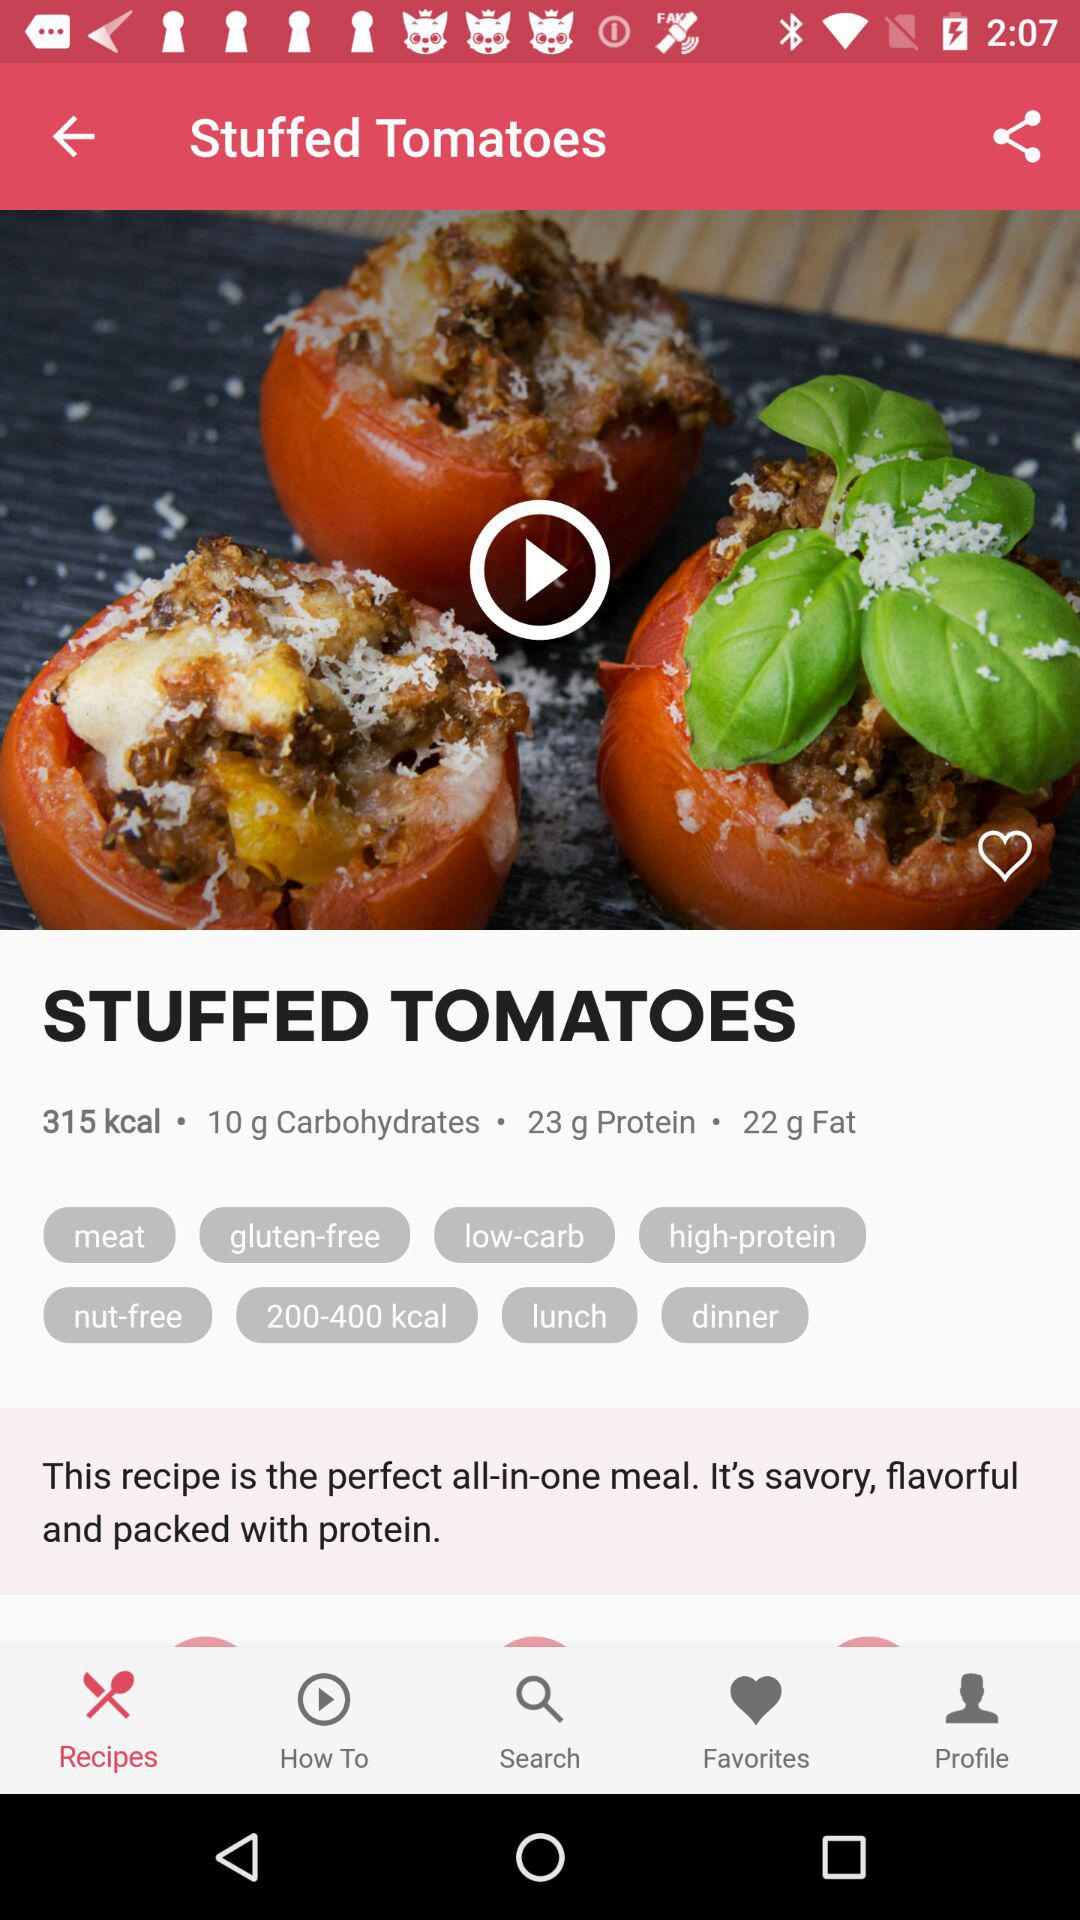How much fat is in the dish? There is 22 g of fat in the dish. 